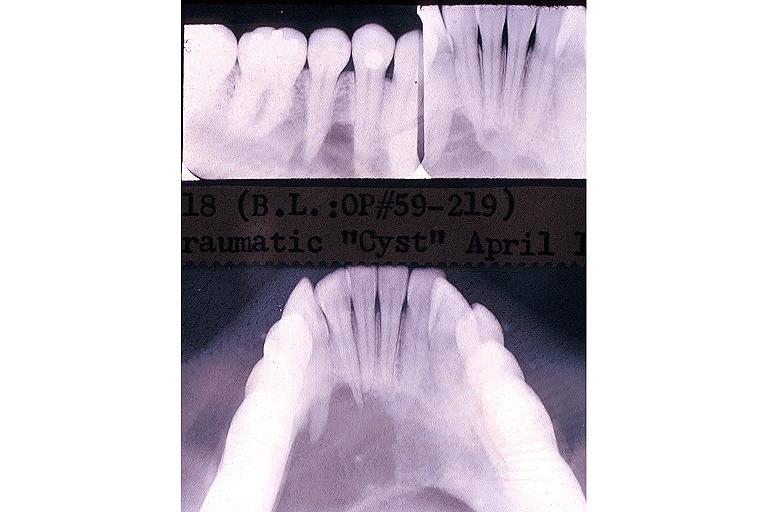what does this image show?
Answer the question using a single word or phrase. Traumatic bone cyst simple bone cyst 